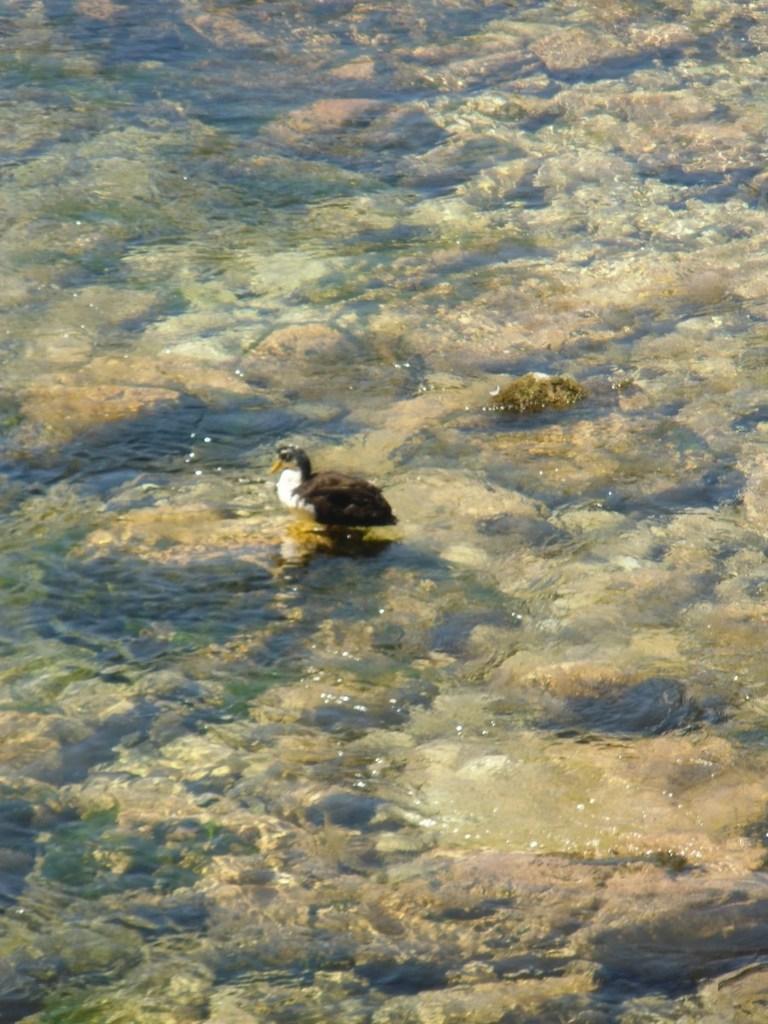Can you describe this image briefly? In this picture there is a duck on the water and there are stones under the water. 